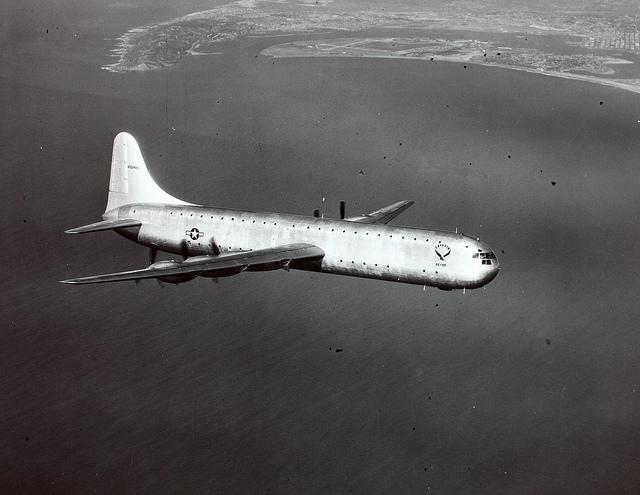Does this plane look vintage?
Quick response, please. Yes. What is the plane flying over?
Be succinct. Water. Is the plane powered by propellers?
Give a very brief answer. No. 